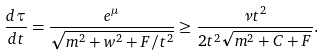<formula> <loc_0><loc_0><loc_500><loc_500>\frac { d \tau } { d t } = \frac { e ^ { \mu } } { \sqrt { m ^ { 2 } + w ^ { 2 } + F / t ^ { 2 } } } \geq \frac { \nu t ^ { 2 } } { 2 t ^ { 2 } \sqrt { m ^ { 2 } + C + F } } .</formula> 